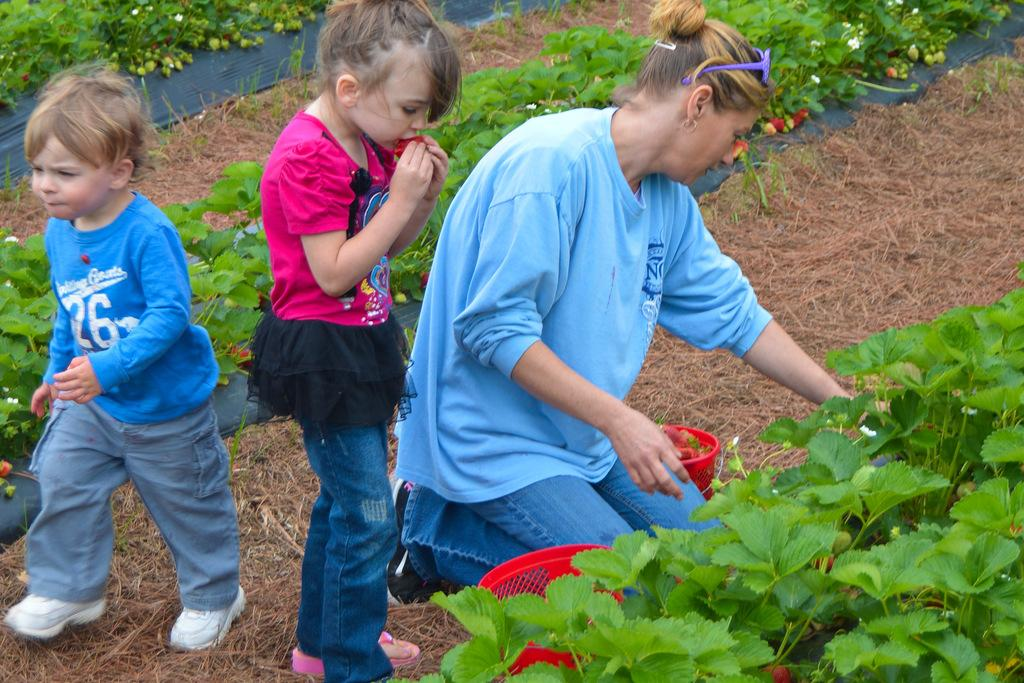What is the woman doing in the image? The woman is sitting in the squat position in the image. How many kids are in the image? There are two kids standing in the image. What type of vegetation can be seen in the image? Plants and dried grass are visible in the image. What objects are present in the image? There are baskets in the image. What type of pencil is the woman using to draw in the image? There is no pencil present in the image, and the woman is not drawing. What is the name of the son standing next to the woman in the image? There is no son mentioned in the image, and the woman is not accompanied by a child. 